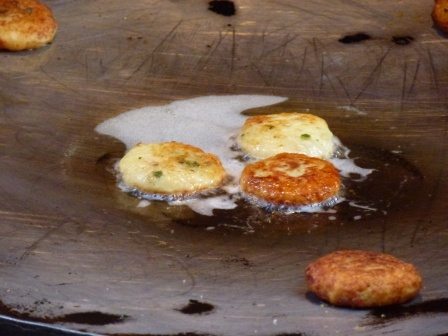Imagine a story that might be associated with this cooking scene. In a cozy kitchen bathed in the morning sun, a young chef named Mia was preparing her grandmother's secret pancake recipe. The aroma of batter sizzling mixed with chives filled the air, stirring nostalgic memories. Each pancake represented a cherished moment from her childhood, evoking laughter-filled breakfasts at her grandmother's countryside home. As Mia watched them turn golden brown, she felt a connection to the past, knowing that these pancakes would soon bring joy and warmth to her own family. 